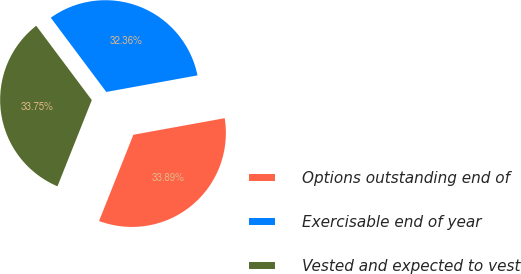Convert chart. <chart><loc_0><loc_0><loc_500><loc_500><pie_chart><fcel>Options outstanding end of<fcel>Exercisable end of year<fcel>Vested and expected to vest<nl><fcel>33.89%<fcel>32.36%<fcel>33.75%<nl></chart> 